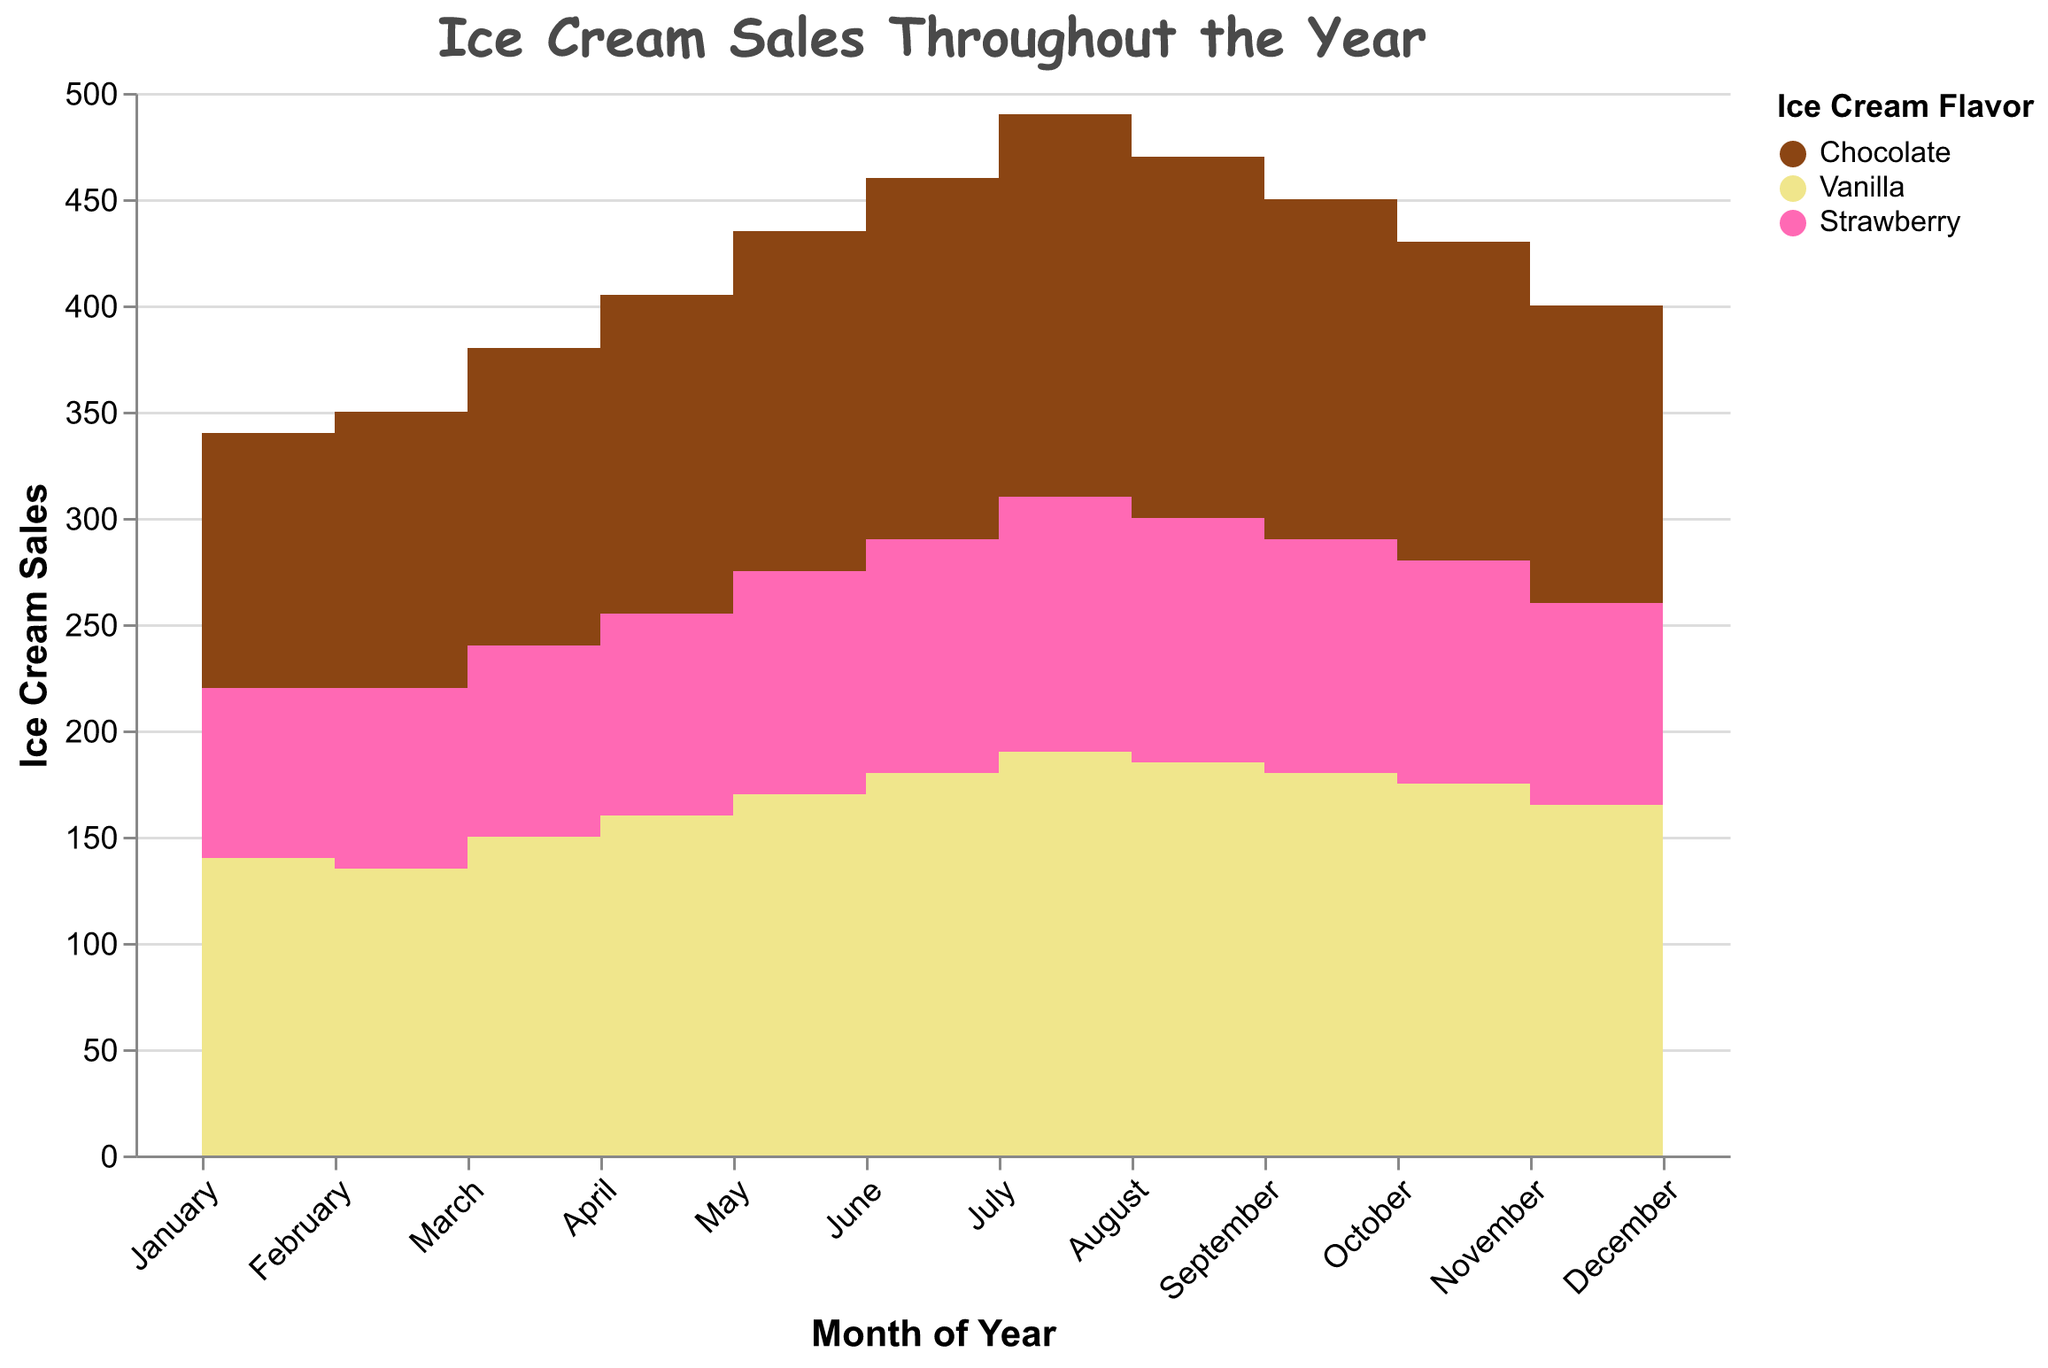What the flavor with the highest sales in July? In July, the step area chart shows the highest sales for Vanilla. Looking at the vertical axis corresponding to sales amount, Vanilla tops the sales in July.
Answer: Vanilla Which month have the lowest sales for Strawberry? Checking the step area chart, the lowest dip for Strawberry sales occur in January and December; both months show sales of 85 units.
Answer: January and December How much the sales for Chocolate go up from January to July? Chocolate starts at 120 units in January and rises to 180 units in July. Subtracting the sales in January from July: 180 - 120 = 60 units.
Answer: 60 units Which flavor is the most popular in December? Looking at December on the chart, Vanilla has the highest sales, leading all ice cream flavors.
Answer: Vanilla How many months did Vanilla sales stay above 160 units? Vanilla sales exceed 160 units from May through December, which totals 8 months (May, June, July, August, September, October, November, December).
Answer: 8 months By how more did the sales of Vanilla increase from January to June than the sales of Strawberry over the same period? For Vanilla: January (140) to June (180) is an increase of 40 units. For Strawberry: January (80) to June (110) is an increase of 30 units. The difference is 40 - 30 = 10 units.
Answer: 10 units What the months where all flavors have seen sales decrease compared to the previous month? The months indicating declining sales for all flavors are August to September and July to August shows a decrease sequentially across Chocolate, Vanilla, and Strawberry flavors.
Answer: August to September Which flavor sees the most sales growth from the beginning to the peak in sales over any period in the year? Chocolate grows from 120 (January) to 180 (July), a maximum growth of 60 units. Comparing to Vanilla and Strawberry's growth, Chocolate has a lesser growth (Vanilla: 140 to 190 = 50 units, Strawberry: 80 to 120 = 40). So, Vanilla sees the maximum growth.
Answer: Vanilla What is average sales for Strawberry between March and June? The sales for Strawberry are 90 (March), 95 (April), 105 (May), and 110 (June). Summing these up: 90 + 95 + 105 + 110 = 400 and dividing by 4 months: 400/4 = 100 units on average.
Answer: 100 units 